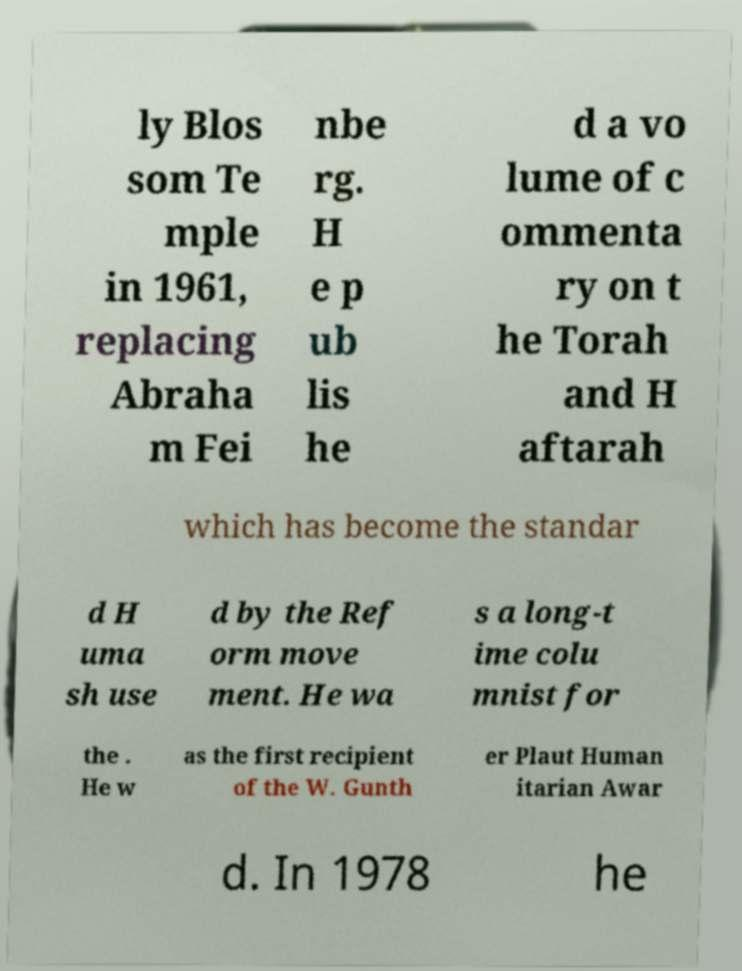Can you accurately transcribe the text from the provided image for me? ly Blos som Te mple in 1961, replacing Abraha m Fei nbe rg. H e p ub lis he d a vo lume of c ommenta ry on t he Torah and H aftarah which has become the standar d H uma sh use d by the Ref orm move ment. He wa s a long-t ime colu mnist for the . He w as the first recipient of the W. Gunth er Plaut Human itarian Awar d. In 1978 he 